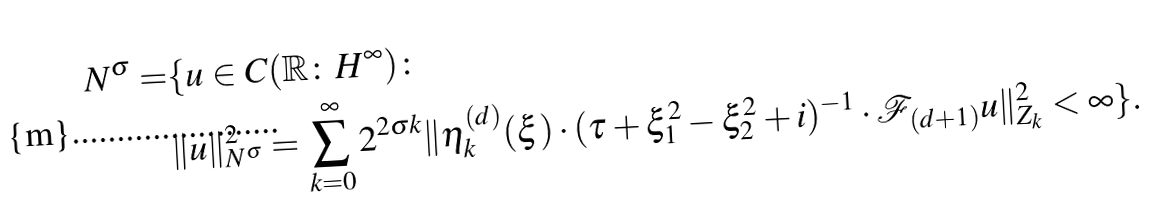Convert formula to latex. <formula><loc_0><loc_0><loc_500><loc_500>N ^ { \sigma } = & \{ u \in C ( \mathbb { R } \colon H ^ { \infty } ) \colon \\ & \| u \| _ { N ^ { \sigma } } ^ { 2 } = \sum _ { k = 0 } ^ { \infty } 2 ^ { 2 \sigma k } \| \eta _ { k } ^ { ( d ) } ( \xi ) \cdot ( \tau + \xi _ { 1 } ^ { 2 } - \xi _ { 2 } ^ { 2 } + i ) ^ { - 1 } \cdot \mathcal { F } _ { ( d + 1 ) } u \| _ { Z _ { k } } ^ { 2 } < \infty \} .</formula> 